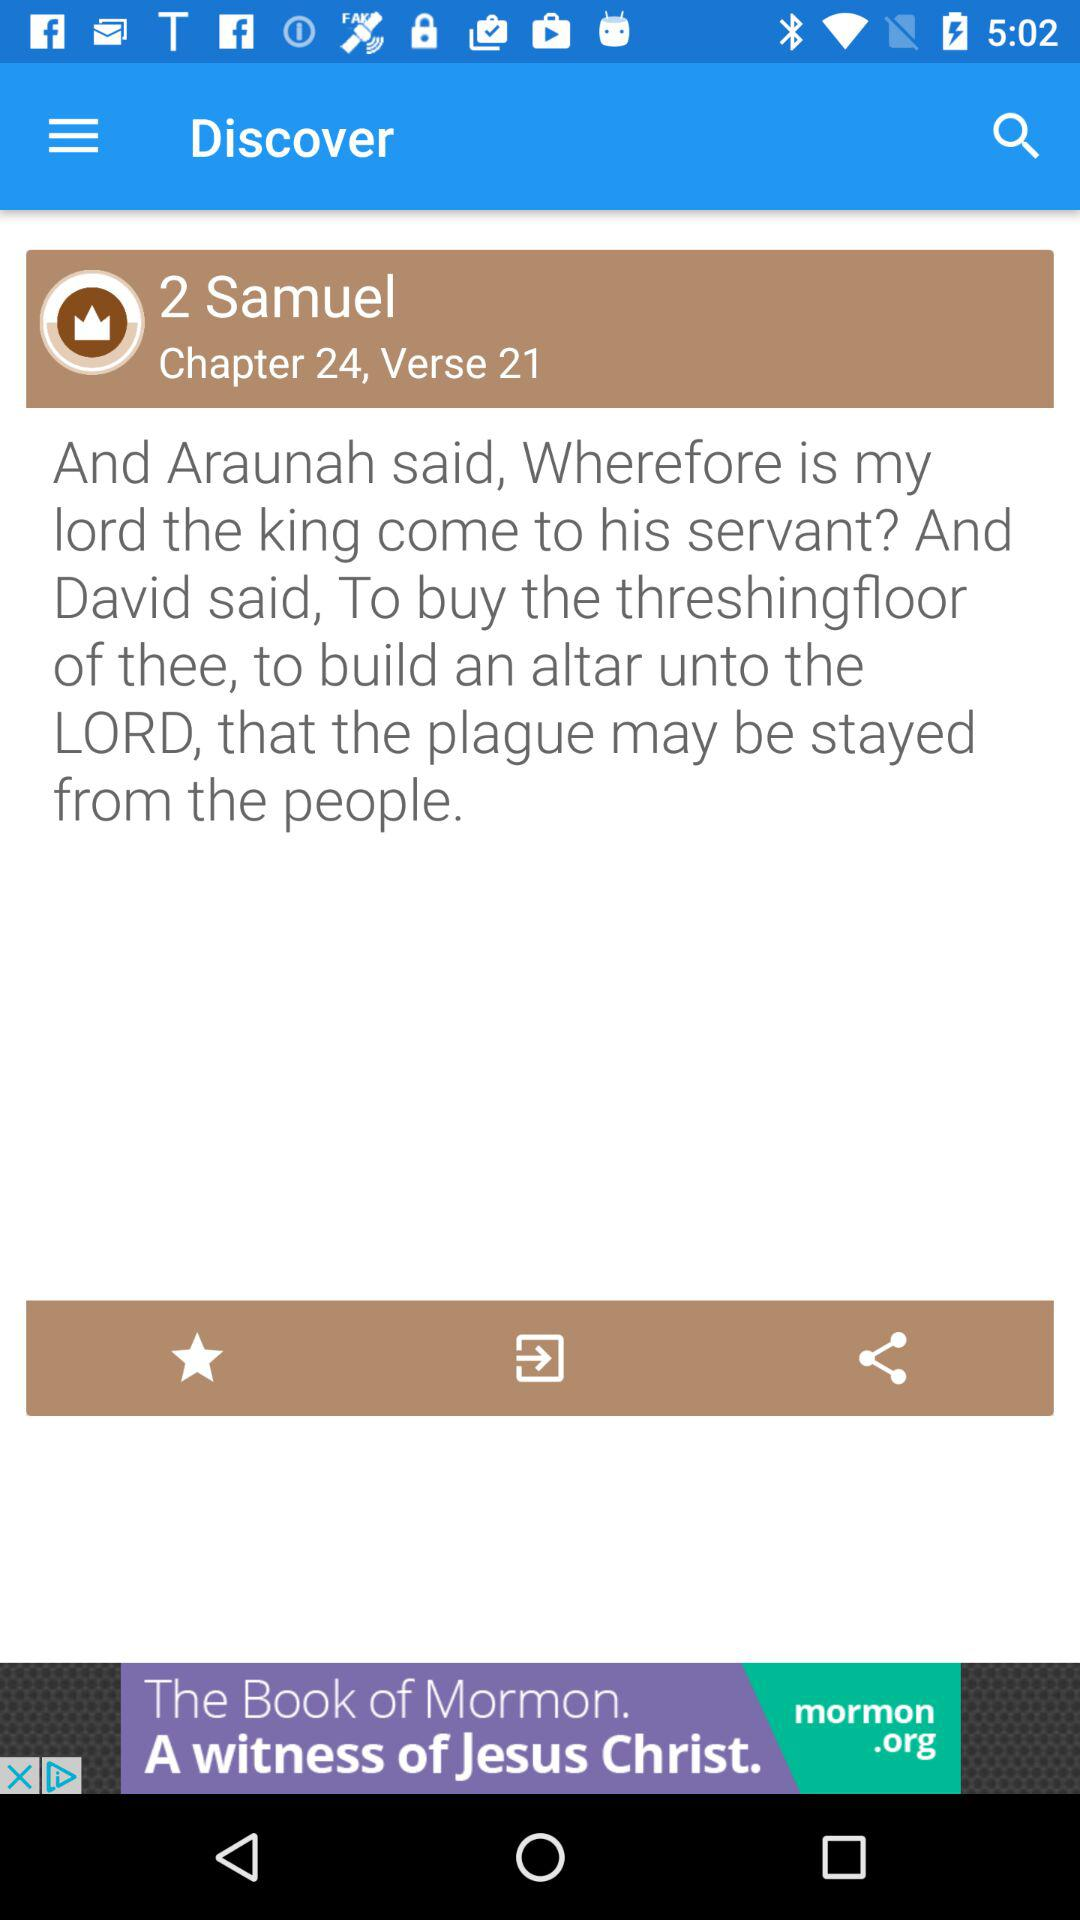From which chapter is the given verse? The given verse is from Chapter 24. 